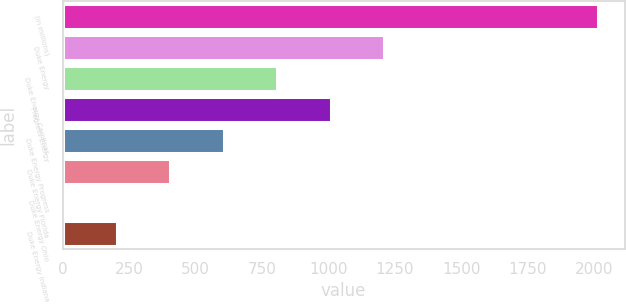Convert chart to OTSL. <chart><loc_0><loc_0><loc_500><loc_500><bar_chart><fcel>(in millions)<fcel>Duke Energy<fcel>Duke Energy Carolinas<fcel>Progress Energy<fcel>Duke Energy Progress<fcel>Duke Energy Florida<fcel>Duke Energy Ohio<fcel>Duke Energy Indiana<nl><fcel>2015<fcel>1209.8<fcel>807.2<fcel>1008.5<fcel>605.9<fcel>404.6<fcel>2<fcel>203.3<nl></chart> 